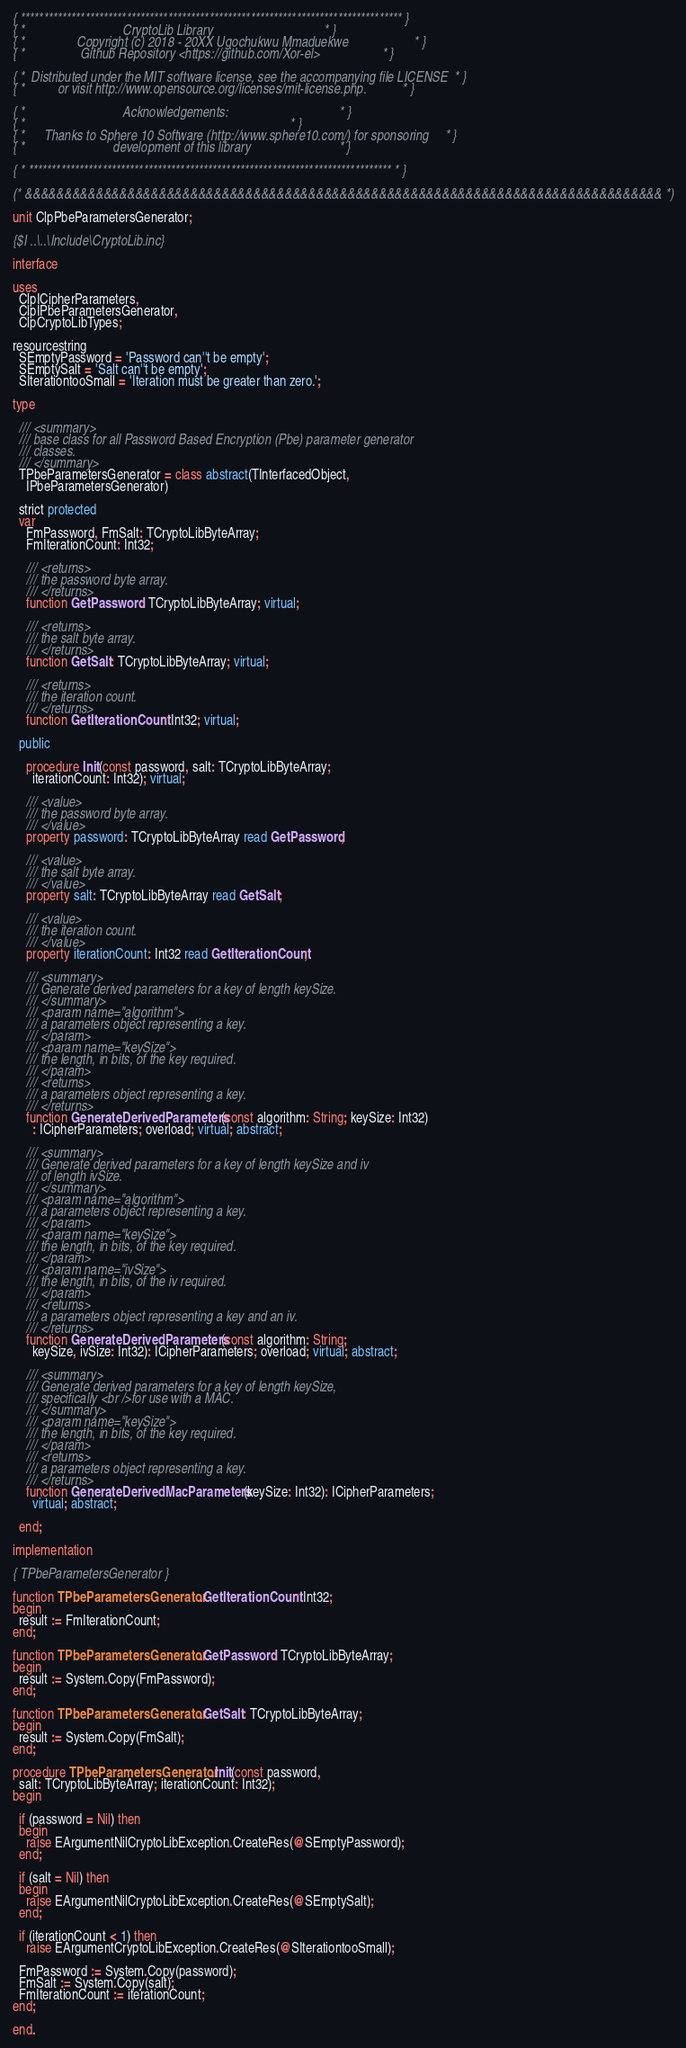<code> <loc_0><loc_0><loc_500><loc_500><_Pascal_>{ *********************************************************************************** }
{ *                              CryptoLib Library                                  * }
{ *                Copyright (c) 2018 - 20XX Ugochukwu Mmaduekwe                    * }
{ *                 Github Repository <https://github.com/Xor-el>                   * }

{ *  Distributed under the MIT software license, see the accompanying file LICENSE  * }
{ *          or visit http://www.opensource.org/licenses/mit-license.php.           * }

{ *                              Acknowledgements:                                  * }
{ *                                                                                 * }
{ *      Thanks to Sphere 10 Software (http://www.sphere10.com/) for sponsoring     * }
{ *                           development of this library                           * }

{ * ******************************************************************************* * }

(* &&&&&&&&&&&&&&&&&&&&&&&&&&&&&&&&&&&&&&&&&&&&&&&&&&&&&&&&&&&&&&&&&&&&&&&&&&&&&&&&& *)

unit ClpPbeParametersGenerator;

{$I ..\..\Include\CryptoLib.inc}

interface

uses
  ClpICipherParameters,
  ClpIPbeParametersGenerator,
  ClpCryptoLibTypes;

resourcestring
  SEmptyPassword = 'Password can''t be empty';
  SEmptySalt = 'Salt can''t be empty';
  SIterationtooSmall = 'Iteration must be greater than zero.';

type

  /// <summary>
  /// base class for all Password Based Encryption (Pbe) parameter generator
  /// classes.
  /// </summary>
  TPbeParametersGenerator = class abstract(TInterfacedObject,
    IPbeParametersGenerator)

  strict protected
  var
    FmPassword, FmSalt: TCryptoLibByteArray;
    FmIterationCount: Int32;

    /// <returns>
    /// the password byte array.
    /// </returns>
    function GetPassword: TCryptoLibByteArray; virtual;

    /// <returns>
    /// the salt byte array.
    /// </returns>
    function GetSalt: TCryptoLibByteArray; virtual;

    /// <returns>
    /// the iteration count.
    /// </returns>
    function GetIterationCount: Int32; virtual;

  public

    procedure Init(const password, salt: TCryptoLibByteArray;
      iterationCount: Int32); virtual;

    /// <value>
    /// the password byte array.
    /// </value>
    property password: TCryptoLibByteArray read GetPassword;

    /// <value>
    /// the salt byte array.
    /// </value>
    property salt: TCryptoLibByteArray read GetSalt;

    /// <value>
    /// the iteration count.
    /// </value>
    property iterationCount: Int32 read GetIterationCount;

    /// <summary>
    /// Generate derived parameters for a key of length keySize.
    /// </summary>
    /// <param name="algorithm">
    /// a parameters object representing a key.
    /// </param>
    /// <param name="keySize">
    /// the length, in bits, of the key required.
    /// </param>
    /// <returns>
    /// a parameters object representing a key.
    /// </returns>
    function GenerateDerivedParameters(const algorithm: String; keySize: Int32)
      : ICipherParameters; overload; virtual; abstract;

    /// <summary>
    /// Generate derived parameters for a key of length keySize and iv
    /// of length ivSize.
    /// </summary>
    /// <param name="algorithm">
    /// a parameters object representing a key.
    /// </param>
    /// <param name="keySize">
    /// the length, in bits, of the key required.
    /// </param>
    /// <param name="ivSize">
    /// the length, in bits, of the iv required.
    /// </param>
    /// <returns>
    /// a parameters object representing a key and an iv.
    /// </returns>
    function GenerateDerivedParameters(const algorithm: String;
      keySize, ivSize: Int32): ICipherParameters; overload; virtual; abstract;

    /// <summary>
    /// Generate derived parameters for a key of length keySize,
    /// specifically <br />for use with a MAC.
    /// </summary>
    /// <param name="keySize">
    /// the length, in bits, of the key required.
    /// </param>
    /// <returns>
    /// a parameters object representing a key.
    /// </returns>
    function GenerateDerivedMacParameters(keySize: Int32): ICipherParameters;
      virtual; abstract;

  end;

implementation

{ TPbeParametersGenerator }

function TPbeParametersGenerator.GetIterationCount: Int32;
begin
  result := FmIterationCount;
end;

function TPbeParametersGenerator.GetPassword: TCryptoLibByteArray;
begin
  result := System.Copy(FmPassword);
end;

function TPbeParametersGenerator.GetSalt: TCryptoLibByteArray;
begin
  result := System.Copy(FmSalt);
end;

procedure TPbeParametersGenerator.Init(const password,
  salt: TCryptoLibByteArray; iterationCount: Int32);
begin

  if (password = Nil) then
  begin
    raise EArgumentNilCryptoLibException.CreateRes(@SEmptyPassword);
  end;

  if (salt = Nil) then
  begin
    raise EArgumentNilCryptoLibException.CreateRes(@SEmptySalt);
  end;

  if (iterationCount < 1) then
    raise EArgumentCryptoLibException.CreateRes(@SIterationtooSmall);

  FmPassword := System.Copy(password);
  FmSalt := System.Copy(salt);
  FmIterationCount := iterationCount;
end;

end.
</code> 